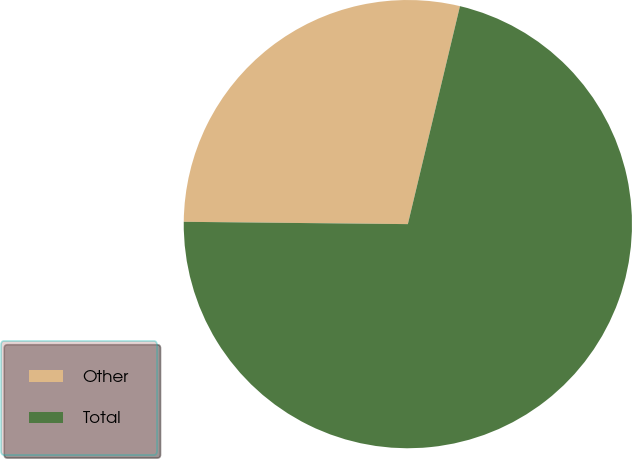Convert chart to OTSL. <chart><loc_0><loc_0><loc_500><loc_500><pie_chart><fcel>Other<fcel>Total<nl><fcel>28.57%<fcel>71.43%<nl></chart> 